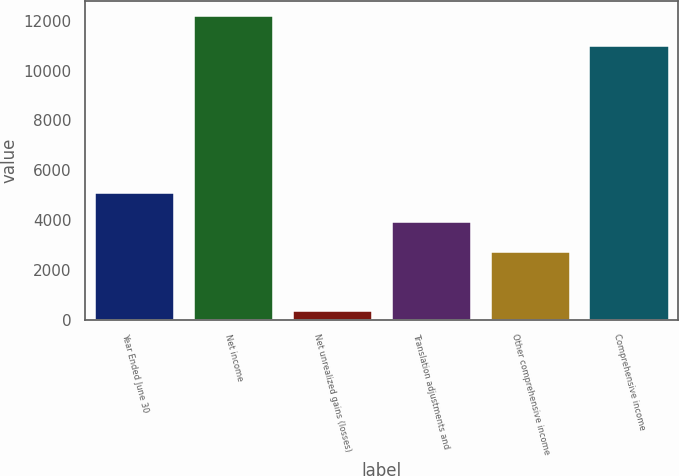Convert chart to OTSL. <chart><loc_0><loc_0><loc_500><loc_500><bar_chart><fcel>Year Ended June 30<fcel>Net income<fcel>Net unrealized gains (losses)<fcel>Translation adjustments and<fcel>Other comprehensive income<fcel>Comprehensive income<nl><fcel>5094.4<fcel>12193<fcel>362<fcel>3911.3<fcel>2728.2<fcel>11007<nl></chart> 